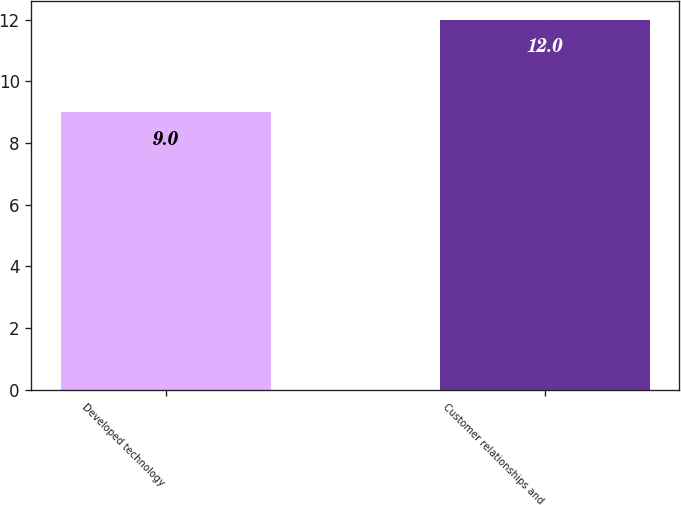Convert chart to OTSL. <chart><loc_0><loc_0><loc_500><loc_500><bar_chart><fcel>Developed technology<fcel>Customer relationships and<nl><fcel>9<fcel>12<nl></chart> 